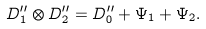<formula> <loc_0><loc_0><loc_500><loc_500>D _ { 1 } ^ { \prime \prime } \otimes D _ { 2 } ^ { \prime \prime } = D _ { 0 } ^ { \prime \prime } + \Psi _ { 1 } + \Psi _ { 2 } .</formula> 